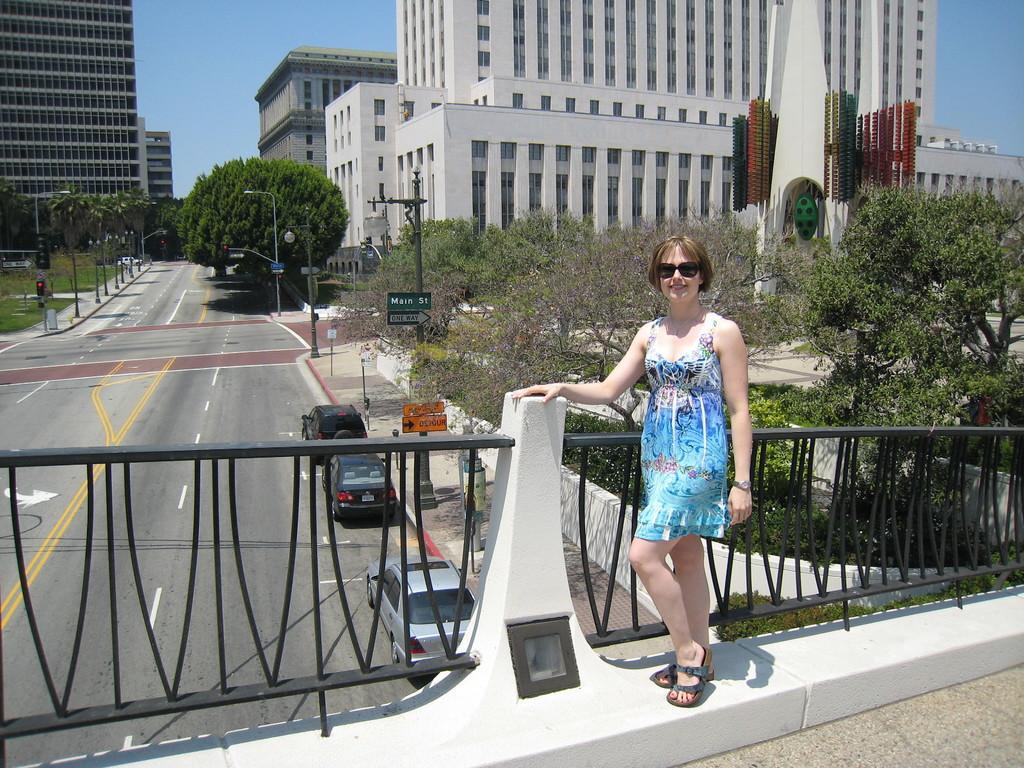In one or two sentences, can you explain what this image depicts? In this picture we can see vehicles on the road, fence, poles, name boards, trees, buildings, grass and some objects and a woman wore goggles and standing and smiling and in the background we can see the sky. 